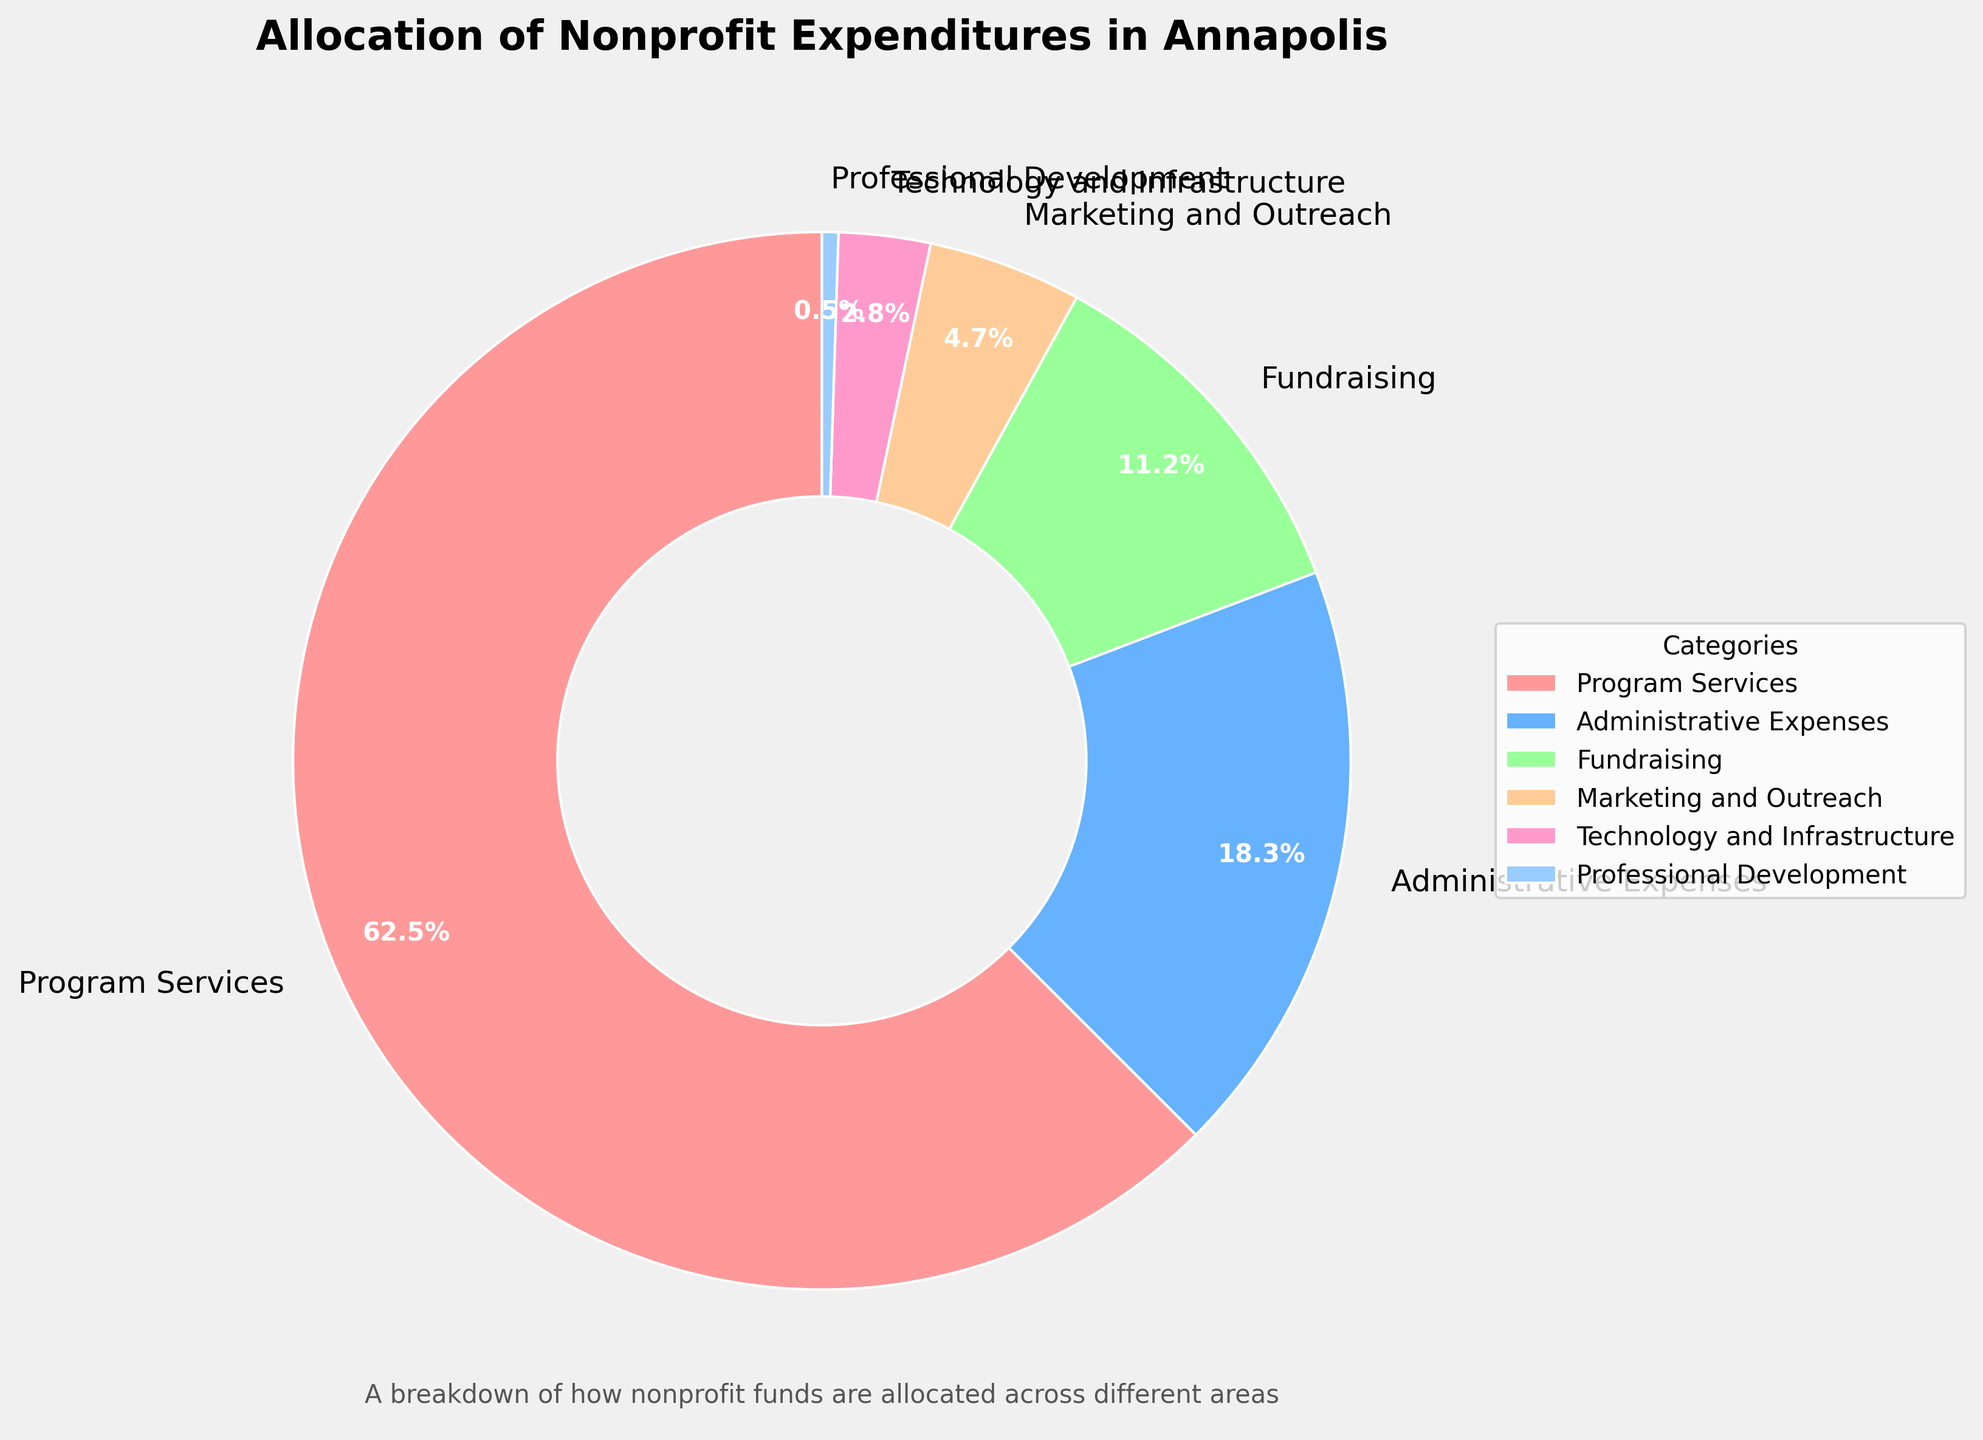Which category has the highest expenditure percentage? By looking at the pie chart, the category with the largest segment represents the highest expenditure percentage. From the chart, Program Services has the largest segment.
Answer: Program Services How much more percentage is allocated to Program Services compared to Administrative Expenses? We subtract the percentage of Administrative Expenses from Program Services: 62.5% - 18.3% = 44.2%.
Answer: 44.2% What is the combined percentage of Technology and Infrastructure and Professional Development? We add the percentages of Technology and Infrastructure and Professional Development: 2.8% + 0.5% = 3.3%.
Answer: 3.3% Which two categories have the smallest expenditure percentages? The pie chart shows that the two smallest segments are Professional Development and Technology and Infrastructure.
Answer: Professional Development and Technology and Infrastructure If Fundraising expenses are increased by 5% and all other categories remain the same, what would be the new percentage allocation for Fundraising? We add 5% to the current Fundraising percentage: 11.2% + 5% = 16.2%.
Answer: 16.2% Which segment is represented by the blue color? By identifying the color in the pie chart, the blue segment corresponds to Administrative Expenses.
Answer: Administrative Expenses Is the percentage for Marketing and Outreach greater than, less than, or equal to one-third of the percentage for Program Services? One-third of the Program Services percentage is: 62.5% / 3 ≈ 20.83%. Since Marketing and Outreach is 4.7%, it is less than one-third of Program Services.
Answer: Less than What is the average percentage allocation of all categories? Add all percentages and divide by the number of categories: (62.5% + 18.3% + 11.2% + 4.7% + 2.8% + 0.5%) / 6 = 16.67%.
Answer: 16.67% Where is the legend positioned in the chart? The legend is positioned on the left side of the chart, outside of the pie chart area.
Answer: Left side If combined, would the percentages of Fundraising and Administrative Expenses be higher than Program Services? Add Fundraising and Administrative Expenses: 11.2% + 18.3% = 29.5%. Comparing this to Program Services: 62.5%, the combined percentage is lower.
Answer: No 